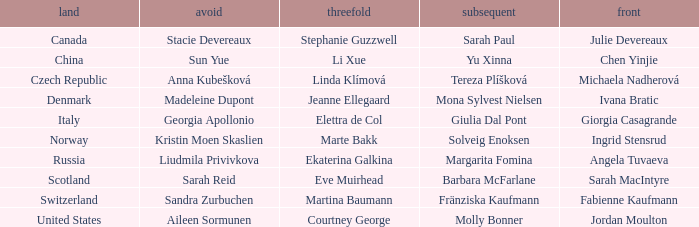What skip has denmark as the country? Madeleine Dupont. 